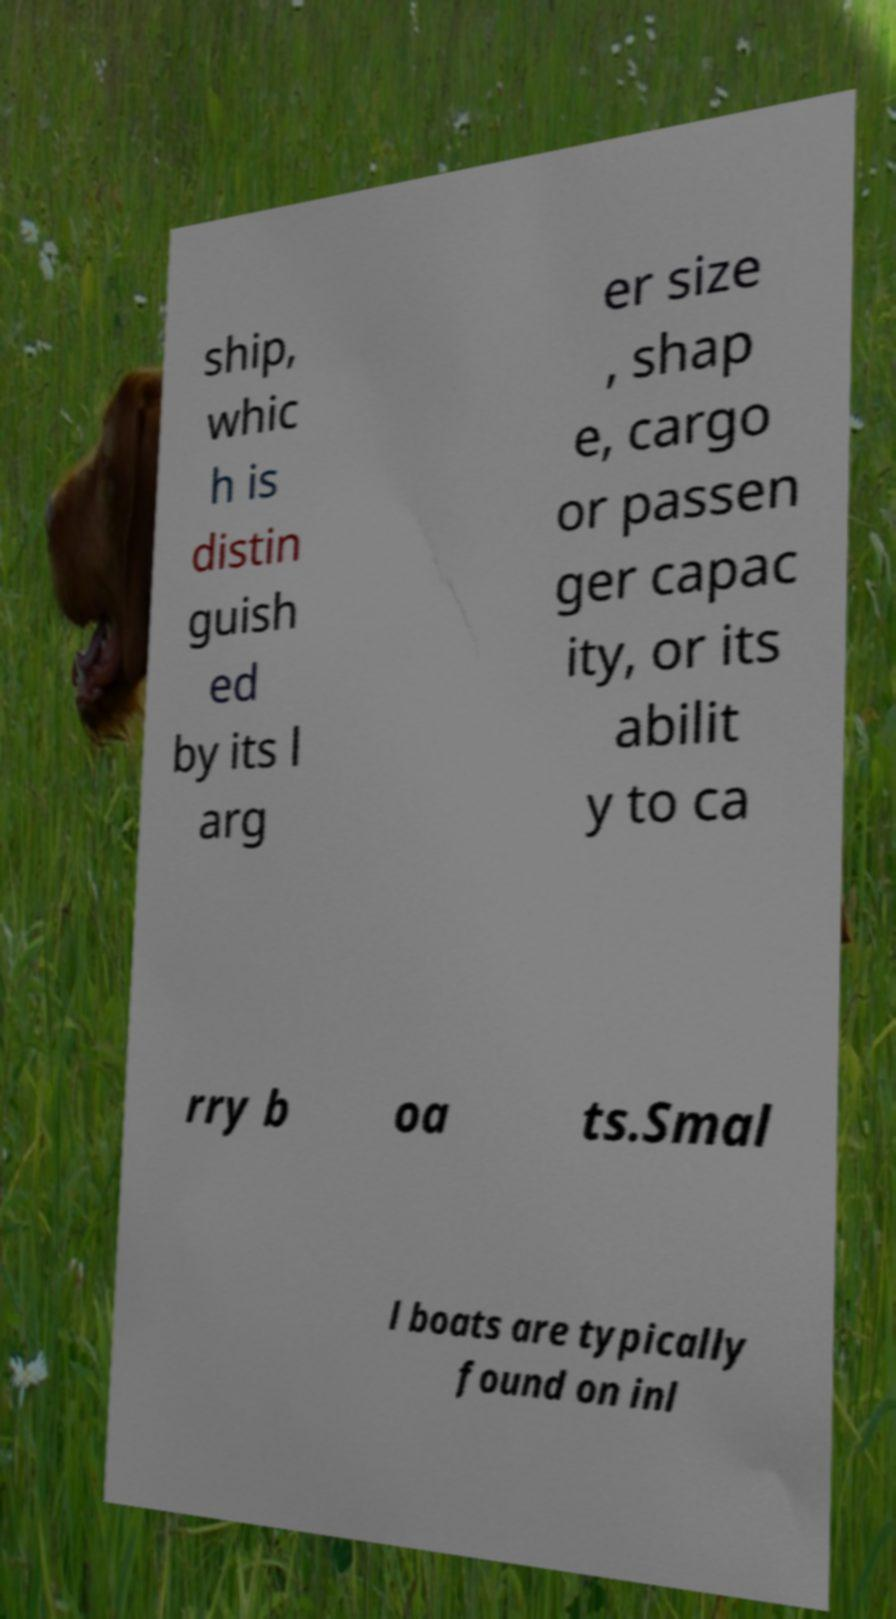For documentation purposes, I need the text within this image transcribed. Could you provide that? ship, whic h is distin guish ed by its l arg er size , shap e, cargo or passen ger capac ity, or its abilit y to ca rry b oa ts.Smal l boats are typically found on inl 